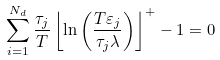<formula> <loc_0><loc_0><loc_500><loc_500>\sum _ { i = 1 } ^ { N _ { d } } \frac { \tau _ { j } } { T } \left \lfloor \ln \left ( \frac { T \varepsilon _ { j } } { \tau _ { j } \lambda } \right ) \right \rfloor ^ { + } - 1 = 0</formula> 